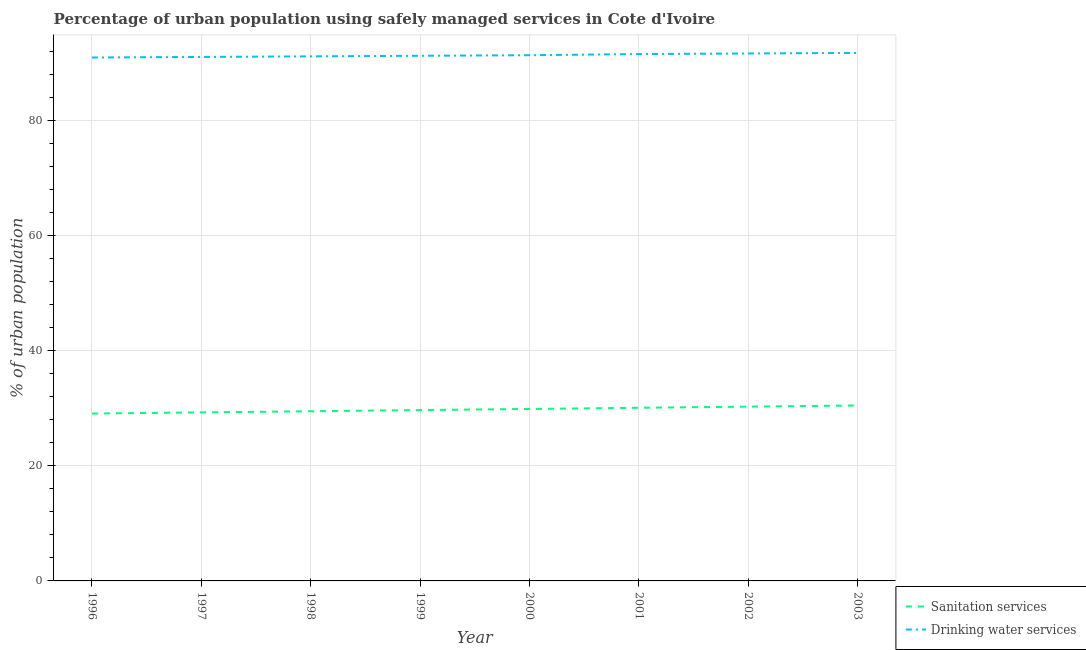Does the line corresponding to percentage of urban population who used drinking water services intersect with the line corresponding to percentage of urban population who used sanitation services?
Give a very brief answer. No. Is the number of lines equal to the number of legend labels?
Provide a succinct answer. Yes. What is the percentage of urban population who used sanitation services in 1997?
Keep it short and to the point. 29.3. Across all years, what is the maximum percentage of urban population who used drinking water services?
Your answer should be very brief. 91.8. Across all years, what is the minimum percentage of urban population who used drinking water services?
Offer a very short reply. 91. In which year was the percentage of urban population who used sanitation services maximum?
Provide a succinct answer. 2003. In which year was the percentage of urban population who used drinking water services minimum?
Give a very brief answer. 1996. What is the total percentage of urban population who used sanitation services in the graph?
Ensure brevity in your answer.  238.4. What is the difference between the percentage of urban population who used drinking water services in 1997 and that in 2000?
Keep it short and to the point. -0.3. What is the difference between the percentage of urban population who used sanitation services in 1999 and the percentage of urban population who used drinking water services in 1998?
Your answer should be compact. -61.5. What is the average percentage of urban population who used sanitation services per year?
Make the answer very short. 29.8. In the year 1997, what is the difference between the percentage of urban population who used sanitation services and percentage of urban population who used drinking water services?
Offer a very short reply. -61.8. In how many years, is the percentage of urban population who used drinking water services greater than 80 %?
Keep it short and to the point. 8. What is the ratio of the percentage of urban population who used drinking water services in 1996 to that in 1998?
Keep it short and to the point. 1. Is the percentage of urban population who used sanitation services in 1996 less than that in 1997?
Make the answer very short. Yes. Is the difference between the percentage of urban population who used sanitation services in 1997 and 2003 greater than the difference between the percentage of urban population who used drinking water services in 1997 and 2003?
Make the answer very short. No. What is the difference between the highest and the second highest percentage of urban population who used sanitation services?
Provide a succinct answer. 0.2. What is the difference between the highest and the lowest percentage of urban population who used sanitation services?
Your response must be concise. 1.4. Is the percentage of urban population who used drinking water services strictly greater than the percentage of urban population who used sanitation services over the years?
Offer a very short reply. Yes. Are the values on the major ticks of Y-axis written in scientific E-notation?
Provide a short and direct response. No. Does the graph contain any zero values?
Provide a succinct answer. No. Does the graph contain grids?
Ensure brevity in your answer.  Yes. Where does the legend appear in the graph?
Give a very brief answer. Bottom right. How are the legend labels stacked?
Your answer should be very brief. Vertical. What is the title of the graph?
Your answer should be very brief. Percentage of urban population using safely managed services in Cote d'Ivoire. What is the label or title of the X-axis?
Offer a very short reply. Year. What is the label or title of the Y-axis?
Your response must be concise. % of urban population. What is the % of urban population in Sanitation services in 1996?
Offer a very short reply. 29.1. What is the % of urban population of Drinking water services in 1996?
Your answer should be very brief. 91. What is the % of urban population of Sanitation services in 1997?
Keep it short and to the point. 29.3. What is the % of urban population in Drinking water services in 1997?
Give a very brief answer. 91.1. What is the % of urban population in Sanitation services in 1998?
Your answer should be compact. 29.5. What is the % of urban population of Drinking water services in 1998?
Provide a succinct answer. 91.2. What is the % of urban population of Sanitation services in 1999?
Provide a short and direct response. 29.7. What is the % of urban population in Drinking water services in 1999?
Your answer should be very brief. 91.3. What is the % of urban population of Sanitation services in 2000?
Offer a terse response. 29.9. What is the % of urban population in Drinking water services in 2000?
Ensure brevity in your answer.  91.4. What is the % of urban population of Sanitation services in 2001?
Ensure brevity in your answer.  30.1. What is the % of urban population of Drinking water services in 2001?
Keep it short and to the point. 91.6. What is the % of urban population in Sanitation services in 2002?
Your answer should be very brief. 30.3. What is the % of urban population in Drinking water services in 2002?
Offer a terse response. 91.7. What is the % of urban population of Sanitation services in 2003?
Your answer should be very brief. 30.5. What is the % of urban population of Drinking water services in 2003?
Make the answer very short. 91.8. Across all years, what is the maximum % of urban population of Sanitation services?
Keep it short and to the point. 30.5. Across all years, what is the maximum % of urban population of Drinking water services?
Make the answer very short. 91.8. Across all years, what is the minimum % of urban population in Sanitation services?
Ensure brevity in your answer.  29.1. Across all years, what is the minimum % of urban population in Drinking water services?
Give a very brief answer. 91. What is the total % of urban population of Sanitation services in the graph?
Your answer should be compact. 238.4. What is the total % of urban population of Drinking water services in the graph?
Keep it short and to the point. 731.1. What is the difference between the % of urban population in Drinking water services in 1996 and that in 1997?
Provide a succinct answer. -0.1. What is the difference between the % of urban population in Sanitation services in 1996 and that in 1998?
Keep it short and to the point. -0.4. What is the difference between the % of urban population of Sanitation services in 1996 and that in 2001?
Make the answer very short. -1. What is the difference between the % of urban population in Drinking water services in 1996 and that in 2001?
Make the answer very short. -0.6. What is the difference between the % of urban population in Drinking water services in 1996 and that in 2002?
Your answer should be very brief. -0.7. What is the difference between the % of urban population in Drinking water services in 1996 and that in 2003?
Offer a very short reply. -0.8. What is the difference between the % of urban population of Sanitation services in 1997 and that in 1998?
Make the answer very short. -0.2. What is the difference between the % of urban population in Drinking water services in 1997 and that in 1998?
Ensure brevity in your answer.  -0.1. What is the difference between the % of urban population in Sanitation services in 1997 and that in 1999?
Your response must be concise. -0.4. What is the difference between the % of urban population of Drinking water services in 1997 and that in 2002?
Offer a very short reply. -0.6. What is the difference between the % of urban population in Drinking water services in 1997 and that in 2003?
Provide a succinct answer. -0.7. What is the difference between the % of urban population of Sanitation services in 1998 and that in 1999?
Offer a terse response. -0.2. What is the difference between the % of urban population in Sanitation services in 1998 and that in 2001?
Your answer should be compact. -0.6. What is the difference between the % of urban population of Sanitation services in 1998 and that in 2002?
Offer a very short reply. -0.8. What is the difference between the % of urban population in Drinking water services in 1998 and that in 2003?
Your response must be concise. -0.6. What is the difference between the % of urban population of Drinking water services in 1999 and that in 2000?
Keep it short and to the point. -0.1. What is the difference between the % of urban population of Drinking water services in 1999 and that in 2001?
Keep it short and to the point. -0.3. What is the difference between the % of urban population of Drinking water services in 1999 and that in 2002?
Provide a succinct answer. -0.4. What is the difference between the % of urban population in Drinking water services in 1999 and that in 2003?
Provide a short and direct response. -0.5. What is the difference between the % of urban population of Drinking water services in 2000 and that in 2001?
Your answer should be compact. -0.2. What is the difference between the % of urban population of Drinking water services in 2000 and that in 2002?
Your answer should be compact. -0.3. What is the difference between the % of urban population in Sanitation services in 2000 and that in 2003?
Your answer should be very brief. -0.6. What is the difference between the % of urban population of Drinking water services in 2000 and that in 2003?
Your answer should be very brief. -0.4. What is the difference between the % of urban population of Sanitation services in 2001 and that in 2002?
Ensure brevity in your answer.  -0.2. What is the difference between the % of urban population of Drinking water services in 2002 and that in 2003?
Provide a succinct answer. -0.1. What is the difference between the % of urban population of Sanitation services in 1996 and the % of urban population of Drinking water services in 1997?
Offer a very short reply. -62. What is the difference between the % of urban population in Sanitation services in 1996 and the % of urban population in Drinking water services in 1998?
Give a very brief answer. -62.1. What is the difference between the % of urban population in Sanitation services in 1996 and the % of urban population in Drinking water services in 1999?
Make the answer very short. -62.2. What is the difference between the % of urban population in Sanitation services in 1996 and the % of urban population in Drinking water services in 2000?
Provide a short and direct response. -62.3. What is the difference between the % of urban population of Sanitation services in 1996 and the % of urban population of Drinking water services in 2001?
Your answer should be compact. -62.5. What is the difference between the % of urban population in Sanitation services in 1996 and the % of urban population in Drinking water services in 2002?
Your answer should be compact. -62.6. What is the difference between the % of urban population of Sanitation services in 1996 and the % of urban population of Drinking water services in 2003?
Your answer should be very brief. -62.7. What is the difference between the % of urban population in Sanitation services in 1997 and the % of urban population in Drinking water services in 1998?
Your answer should be compact. -61.9. What is the difference between the % of urban population in Sanitation services in 1997 and the % of urban population in Drinking water services in 1999?
Keep it short and to the point. -62. What is the difference between the % of urban population in Sanitation services in 1997 and the % of urban population in Drinking water services in 2000?
Keep it short and to the point. -62.1. What is the difference between the % of urban population of Sanitation services in 1997 and the % of urban population of Drinking water services in 2001?
Your answer should be very brief. -62.3. What is the difference between the % of urban population in Sanitation services in 1997 and the % of urban population in Drinking water services in 2002?
Provide a short and direct response. -62.4. What is the difference between the % of urban population of Sanitation services in 1997 and the % of urban population of Drinking water services in 2003?
Keep it short and to the point. -62.5. What is the difference between the % of urban population in Sanitation services in 1998 and the % of urban population in Drinking water services in 1999?
Ensure brevity in your answer.  -61.8. What is the difference between the % of urban population of Sanitation services in 1998 and the % of urban population of Drinking water services in 2000?
Provide a short and direct response. -61.9. What is the difference between the % of urban population of Sanitation services in 1998 and the % of urban population of Drinking water services in 2001?
Make the answer very short. -62.1. What is the difference between the % of urban population in Sanitation services in 1998 and the % of urban population in Drinking water services in 2002?
Make the answer very short. -62.2. What is the difference between the % of urban population in Sanitation services in 1998 and the % of urban population in Drinking water services in 2003?
Your answer should be very brief. -62.3. What is the difference between the % of urban population of Sanitation services in 1999 and the % of urban population of Drinking water services in 2000?
Your answer should be very brief. -61.7. What is the difference between the % of urban population in Sanitation services in 1999 and the % of urban population in Drinking water services in 2001?
Your answer should be very brief. -61.9. What is the difference between the % of urban population in Sanitation services in 1999 and the % of urban population in Drinking water services in 2002?
Ensure brevity in your answer.  -62. What is the difference between the % of urban population in Sanitation services in 1999 and the % of urban population in Drinking water services in 2003?
Ensure brevity in your answer.  -62.1. What is the difference between the % of urban population in Sanitation services in 2000 and the % of urban population in Drinking water services in 2001?
Give a very brief answer. -61.7. What is the difference between the % of urban population in Sanitation services in 2000 and the % of urban population in Drinking water services in 2002?
Make the answer very short. -61.8. What is the difference between the % of urban population in Sanitation services in 2000 and the % of urban population in Drinking water services in 2003?
Provide a short and direct response. -61.9. What is the difference between the % of urban population of Sanitation services in 2001 and the % of urban population of Drinking water services in 2002?
Give a very brief answer. -61.6. What is the difference between the % of urban population in Sanitation services in 2001 and the % of urban population in Drinking water services in 2003?
Provide a short and direct response. -61.7. What is the difference between the % of urban population in Sanitation services in 2002 and the % of urban population in Drinking water services in 2003?
Provide a succinct answer. -61.5. What is the average % of urban population of Sanitation services per year?
Ensure brevity in your answer.  29.8. What is the average % of urban population of Drinking water services per year?
Offer a terse response. 91.39. In the year 1996, what is the difference between the % of urban population in Sanitation services and % of urban population in Drinking water services?
Provide a succinct answer. -61.9. In the year 1997, what is the difference between the % of urban population of Sanitation services and % of urban population of Drinking water services?
Offer a very short reply. -61.8. In the year 1998, what is the difference between the % of urban population in Sanitation services and % of urban population in Drinking water services?
Provide a short and direct response. -61.7. In the year 1999, what is the difference between the % of urban population of Sanitation services and % of urban population of Drinking water services?
Your answer should be compact. -61.6. In the year 2000, what is the difference between the % of urban population in Sanitation services and % of urban population in Drinking water services?
Offer a very short reply. -61.5. In the year 2001, what is the difference between the % of urban population of Sanitation services and % of urban population of Drinking water services?
Your response must be concise. -61.5. In the year 2002, what is the difference between the % of urban population in Sanitation services and % of urban population in Drinking water services?
Give a very brief answer. -61.4. In the year 2003, what is the difference between the % of urban population of Sanitation services and % of urban population of Drinking water services?
Provide a short and direct response. -61.3. What is the ratio of the % of urban population of Drinking water services in 1996 to that in 1997?
Give a very brief answer. 1. What is the ratio of the % of urban population in Sanitation services in 1996 to that in 1998?
Offer a very short reply. 0.99. What is the ratio of the % of urban population of Drinking water services in 1996 to that in 1998?
Offer a very short reply. 1. What is the ratio of the % of urban population of Sanitation services in 1996 to that in 1999?
Ensure brevity in your answer.  0.98. What is the ratio of the % of urban population in Sanitation services in 1996 to that in 2000?
Give a very brief answer. 0.97. What is the ratio of the % of urban population in Sanitation services in 1996 to that in 2001?
Offer a very short reply. 0.97. What is the ratio of the % of urban population in Drinking water services in 1996 to that in 2001?
Provide a succinct answer. 0.99. What is the ratio of the % of urban population of Sanitation services in 1996 to that in 2002?
Make the answer very short. 0.96. What is the ratio of the % of urban population in Drinking water services in 1996 to that in 2002?
Keep it short and to the point. 0.99. What is the ratio of the % of urban population in Sanitation services in 1996 to that in 2003?
Your answer should be very brief. 0.95. What is the ratio of the % of urban population of Sanitation services in 1997 to that in 1998?
Offer a terse response. 0.99. What is the ratio of the % of urban population of Sanitation services in 1997 to that in 1999?
Provide a short and direct response. 0.99. What is the ratio of the % of urban population in Sanitation services in 1997 to that in 2000?
Provide a short and direct response. 0.98. What is the ratio of the % of urban population of Drinking water services in 1997 to that in 2000?
Keep it short and to the point. 1. What is the ratio of the % of urban population of Sanitation services in 1997 to that in 2001?
Keep it short and to the point. 0.97. What is the ratio of the % of urban population of Drinking water services in 1997 to that in 2001?
Keep it short and to the point. 0.99. What is the ratio of the % of urban population of Sanitation services in 1997 to that in 2002?
Offer a very short reply. 0.97. What is the ratio of the % of urban population in Sanitation services in 1997 to that in 2003?
Provide a succinct answer. 0.96. What is the ratio of the % of urban population of Sanitation services in 1998 to that in 1999?
Keep it short and to the point. 0.99. What is the ratio of the % of urban population in Drinking water services in 1998 to that in 1999?
Your response must be concise. 1. What is the ratio of the % of urban population in Sanitation services in 1998 to that in 2000?
Your response must be concise. 0.99. What is the ratio of the % of urban population of Sanitation services in 1998 to that in 2001?
Give a very brief answer. 0.98. What is the ratio of the % of urban population of Drinking water services in 1998 to that in 2001?
Provide a succinct answer. 1. What is the ratio of the % of urban population of Sanitation services in 1998 to that in 2002?
Provide a succinct answer. 0.97. What is the ratio of the % of urban population in Drinking water services in 1998 to that in 2002?
Give a very brief answer. 0.99. What is the ratio of the % of urban population of Sanitation services in 1998 to that in 2003?
Give a very brief answer. 0.97. What is the ratio of the % of urban population of Drinking water services in 1998 to that in 2003?
Make the answer very short. 0.99. What is the ratio of the % of urban population in Drinking water services in 1999 to that in 2000?
Your answer should be very brief. 1. What is the ratio of the % of urban population of Sanitation services in 1999 to that in 2001?
Keep it short and to the point. 0.99. What is the ratio of the % of urban population of Sanitation services in 1999 to that in 2002?
Give a very brief answer. 0.98. What is the ratio of the % of urban population of Drinking water services in 1999 to that in 2002?
Ensure brevity in your answer.  1. What is the ratio of the % of urban population in Sanitation services in 1999 to that in 2003?
Keep it short and to the point. 0.97. What is the ratio of the % of urban population in Sanitation services in 2000 to that in 2002?
Offer a very short reply. 0.99. What is the ratio of the % of urban population of Sanitation services in 2000 to that in 2003?
Your answer should be very brief. 0.98. What is the ratio of the % of urban population in Sanitation services in 2001 to that in 2002?
Ensure brevity in your answer.  0.99. What is the ratio of the % of urban population of Sanitation services in 2001 to that in 2003?
Your answer should be compact. 0.99. What is the ratio of the % of urban population in Drinking water services in 2001 to that in 2003?
Provide a short and direct response. 1. What is the ratio of the % of urban population of Sanitation services in 2002 to that in 2003?
Offer a very short reply. 0.99. What is the ratio of the % of urban population of Drinking water services in 2002 to that in 2003?
Offer a very short reply. 1. What is the difference between the highest and the second highest % of urban population in Sanitation services?
Your response must be concise. 0.2. What is the difference between the highest and the lowest % of urban population in Sanitation services?
Your answer should be compact. 1.4. What is the difference between the highest and the lowest % of urban population in Drinking water services?
Your response must be concise. 0.8. 